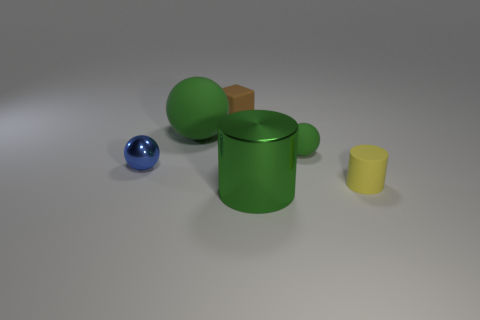Imagine if these objects were part of a child's toy set, how would you describe their potential use or purpose in play? If these objects were part of a child's toy set, one might describe them as elements for creative and educational play. The various shapes could be used to teach about geometry, the concept of volume, or sorting by size and color. Additionally, their differing sizes and weights could offer a tactile experience, useful for developing fine motor skills and spatial awareness during imaginative play. 